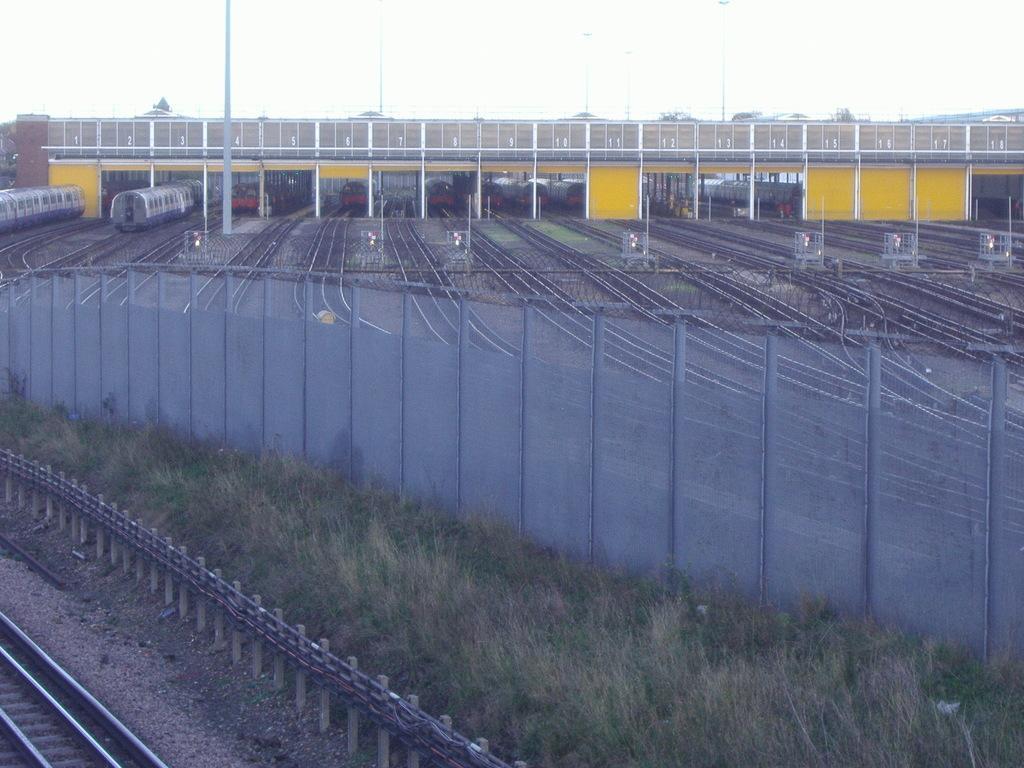Please provide a concise description of this image. In this image on the left side at the bottom corner we can see railway track, fence and grass at the other fence are on the ground. In the background there are trains on the railway tracks, poles, metal objects, trees, bridge and sky. 